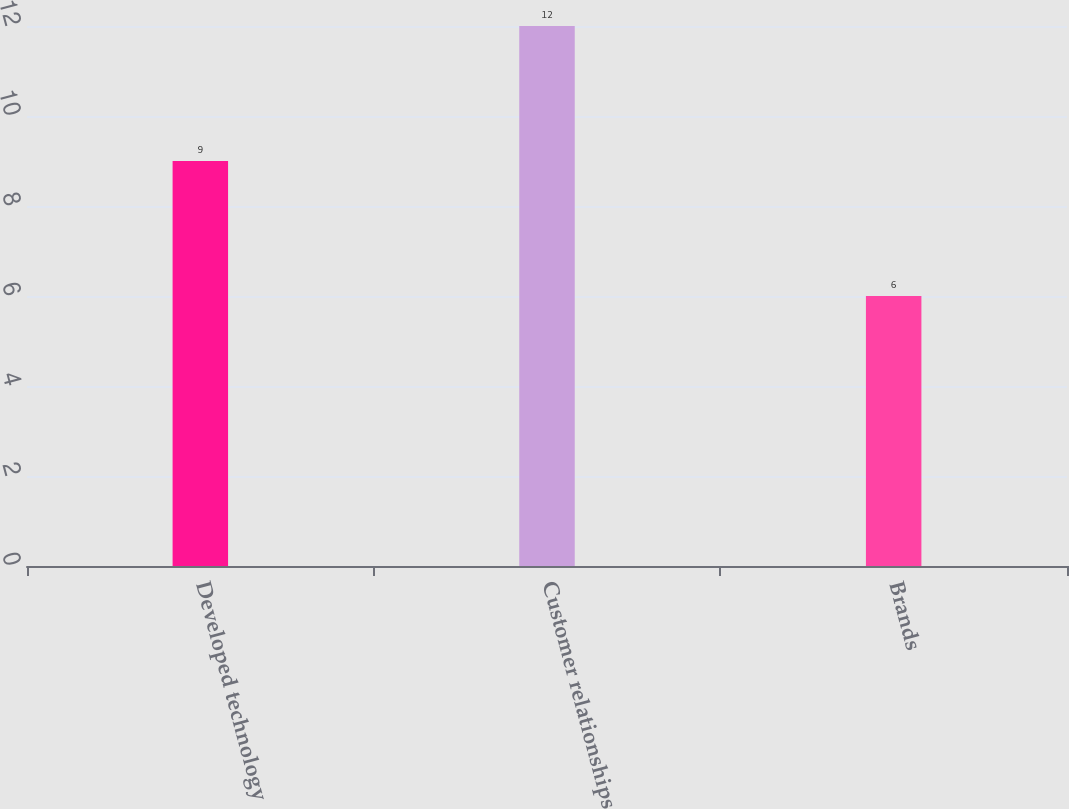Convert chart. <chart><loc_0><loc_0><loc_500><loc_500><bar_chart><fcel>Developed technology<fcel>Customer relationships<fcel>Brands<nl><fcel>9<fcel>12<fcel>6<nl></chart> 